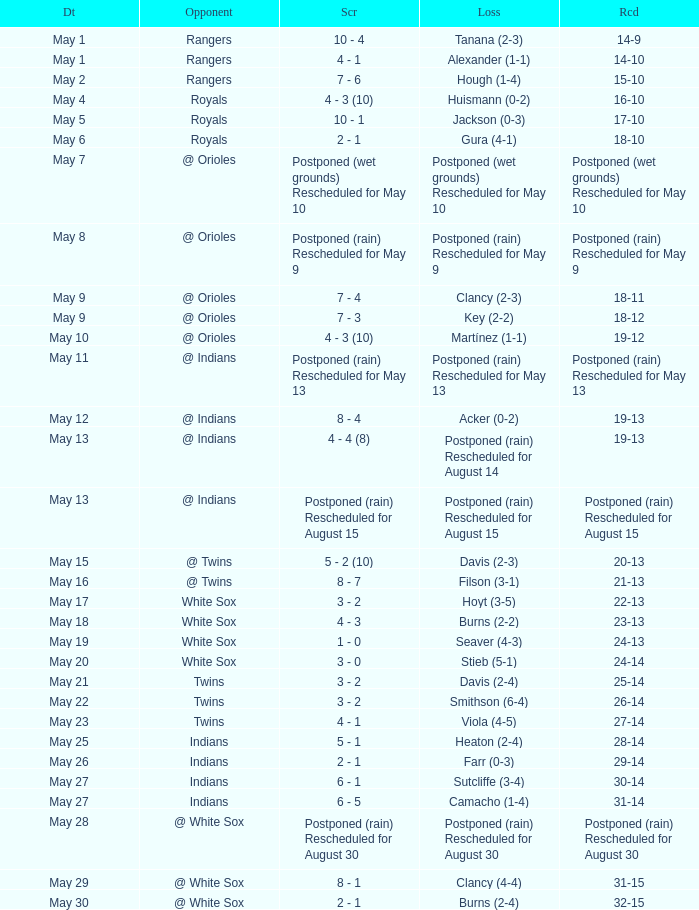What was the date of the match when the score was 31-15? May 29. 